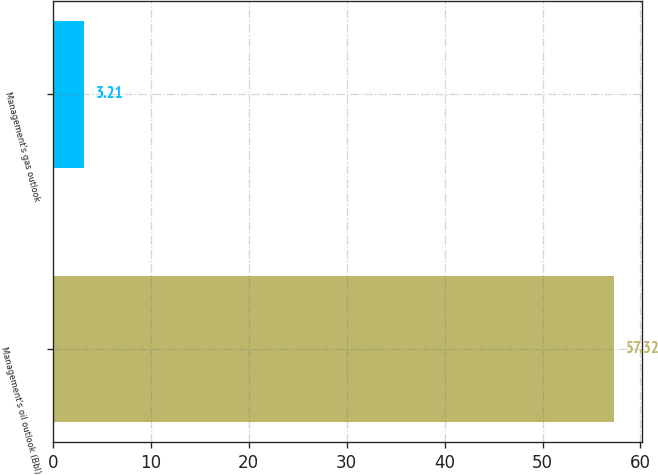<chart> <loc_0><loc_0><loc_500><loc_500><bar_chart><fcel>Management's oil outlook (Bbl)<fcel>Management's gas outlook<nl><fcel>57.32<fcel>3.21<nl></chart> 